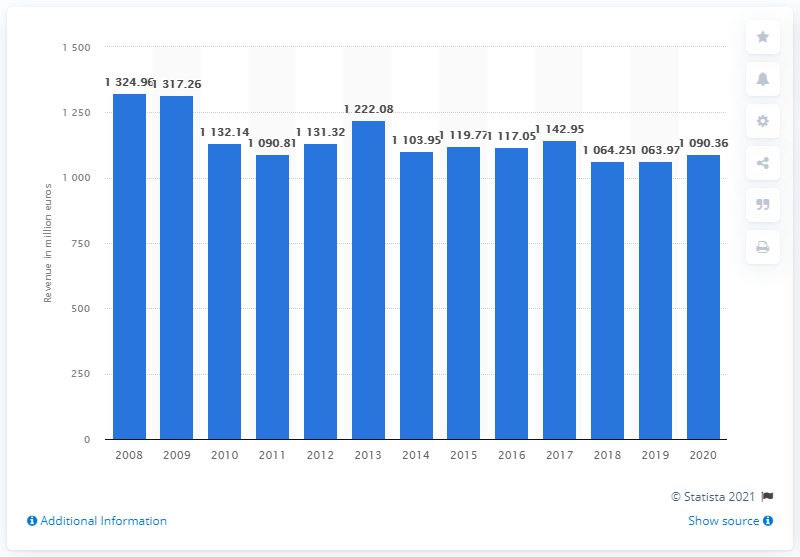List a handful of essential elements in this visual. In 2020, the German ice cream manufacturing industry generated a total revenue of 1090.36 million euros. 